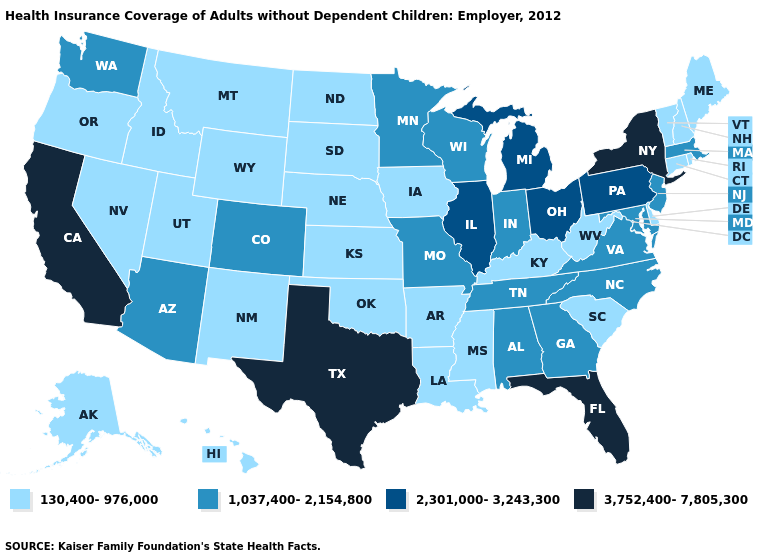Name the states that have a value in the range 2,301,000-3,243,300?
Quick response, please. Illinois, Michigan, Ohio, Pennsylvania. Does Washington have the lowest value in the West?
Short answer required. No. Does Nebraska have the highest value in the USA?
Concise answer only. No. What is the value of Wyoming?
Keep it brief. 130,400-976,000. What is the value of Oklahoma?
Quick response, please. 130,400-976,000. What is the lowest value in the USA?
Give a very brief answer. 130,400-976,000. Name the states that have a value in the range 130,400-976,000?
Quick response, please. Alaska, Arkansas, Connecticut, Delaware, Hawaii, Idaho, Iowa, Kansas, Kentucky, Louisiana, Maine, Mississippi, Montana, Nebraska, Nevada, New Hampshire, New Mexico, North Dakota, Oklahoma, Oregon, Rhode Island, South Carolina, South Dakota, Utah, Vermont, West Virginia, Wyoming. Name the states that have a value in the range 1,037,400-2,154,800?
Short answer required. Alabama, Arizona, Colorado, Georgia, Indiana, Maryland, Massachusetts, Minnesota, Missouri, New Jersey, North Carolina, Tennessee, Virginia, Washington, Wisconsin. What is the value of Washington?
Be succinct. 1,037,400-2,154,800. What is the value of West Virginia?
Quick response, please. 130,400-976,000. Does the map have missing data?
Answer briefly. No. Which states have the lowest value in the West?
Short answer required. Alaska, Hawaii, Idaho, Montana, Nevada, New Mexico, Oregon, Utah, Wyoming. Name the states that have a value in the range 3,752,400-7,805,300?
Concise answer only. California, Florida, New York, Texas. Is the legend a continuous bar?
Concise answer only. No. 